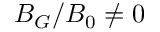<formula> <loc_0><loc_0><loc_500><loc_500>B _ { G } / B _ { 0 } \ne 0</formula> 